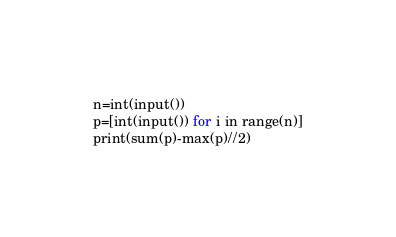Convert code to text. <code><loc_0><loc_0><loc_500><loc_500><_Python_>n=int(input())
p=[int(input()) for i in range(n)]
print(sum(p)-max(p)//2)</code> 